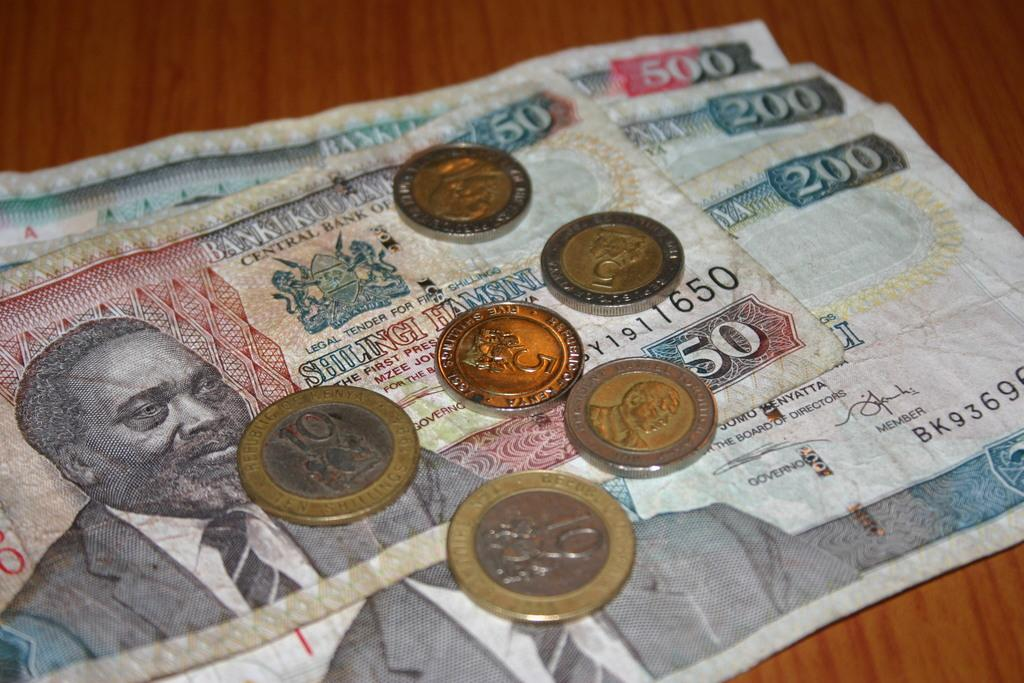<image>
Give a short and clear explanation of the subsequent image. Several coins and paper notes, some notes are 200 and 500 denominations. 